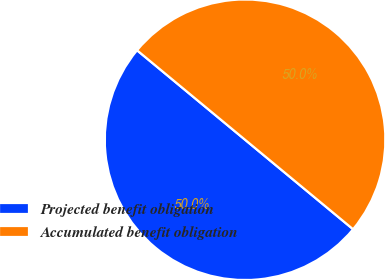Convert chart. <chart><loc_0><loc_0><loc_500><loc_500><pie_chart><fcel>Projected benefit obligation<fcel>Accumulated benefit obligation<nl><fcel>50.0%<fcel>50.0%<nl></chart> 